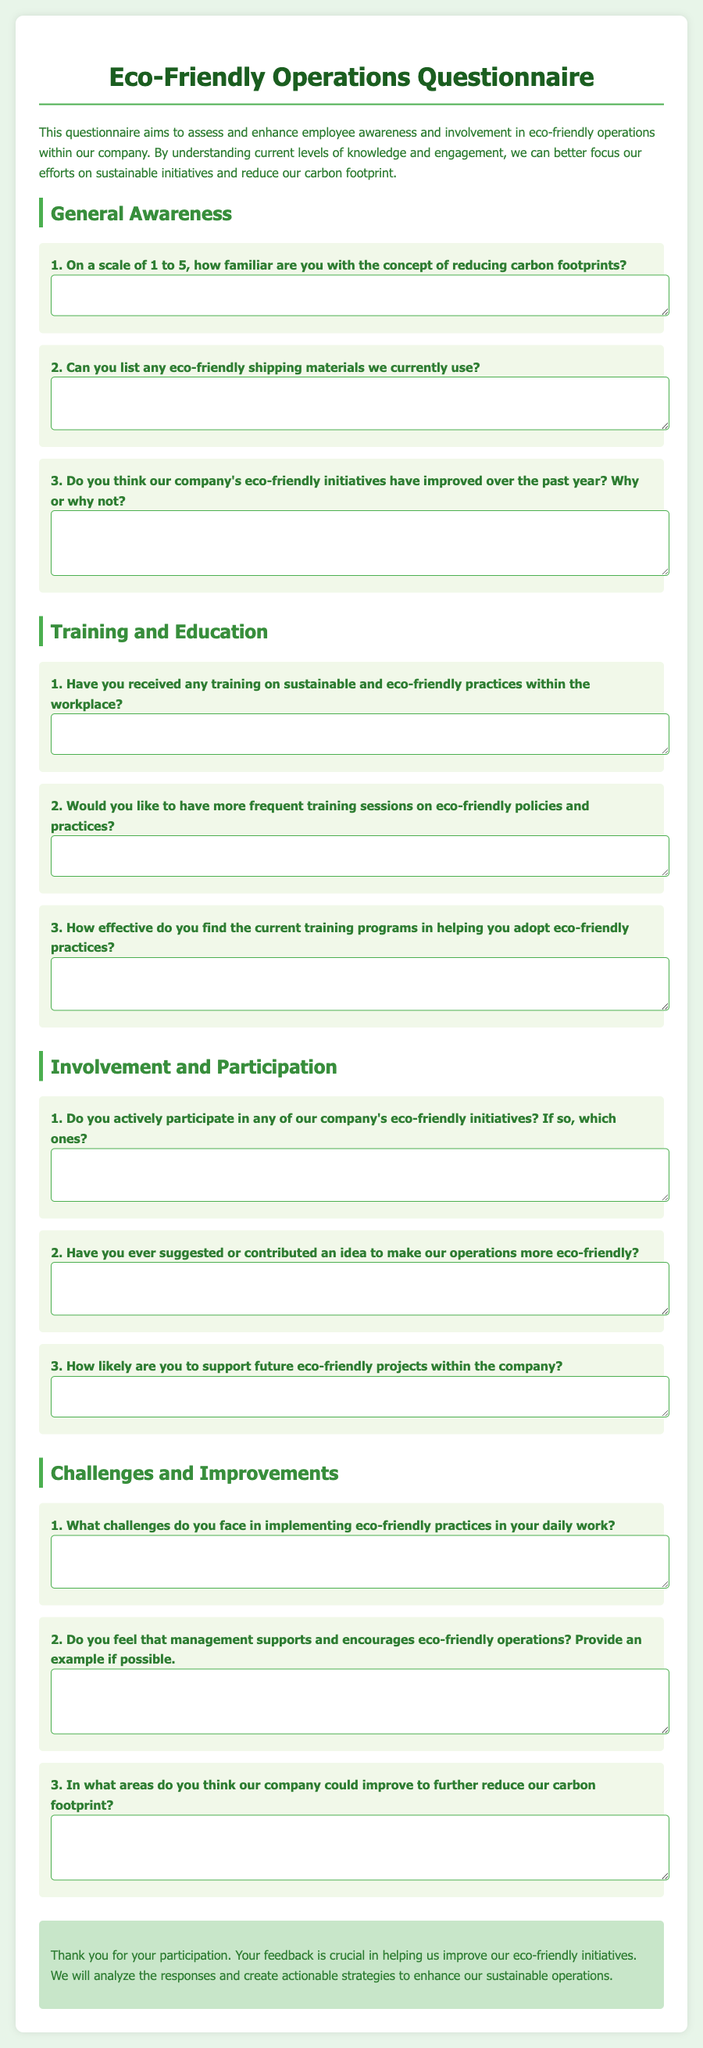What is the title of the document? The title of the document is displayed prominently at the top of the page, indicating the focus of the content.
Answer: Eco-Friendly Operations Questionnaire How many sections are in the document? The document contains multiple sections, each dedicated to different aspects of eco-friendly operations and employee involvement.
Answer: 4 What color is used for the question background? The color of the question background is specified in the style section of the document, showing a clear visual separation for the questions.
Answer: Light green What is the primary purpose of the questionnaire? The introductory paragraph outlines the aim of the questionnaire, highlighting its goals in assessing employee engagement and awareness.
Answer: To assess and enhance employee awareness and involvement in eco-friendly operations What is the last question under the "Challenges and Improvements" section? By reviewing the document, we can identify the final question within the specified section regarding potential improvements.
Answer: In what areas do you think our company could improve to further reduce our carbon footprint? How likely are you to support future eco-friendly projects within the company? This is a specific question asking for involvement, and it requires a participant's response about their future engagement.
Answer: Short answer expected from participants Do you think our company's eco-friendly initiatives have improved over the past year? This is a reasoning question that encourages participants to reflect on the progress of eco-friendly initiatives over time.
Answer: Open-ended response expected from participants How effective do you find the current training programs? This question seeks to gauge participant opinions on the value of existing training efforts related to eco-friendly practices.
Answer: Open-ended response expected from participants Have you ever suggested or contributed an idea? This question encourages employees to reflect on their proactive involvement in eco-friendly initiatives.
Answer: Open-ended response expected from participants 